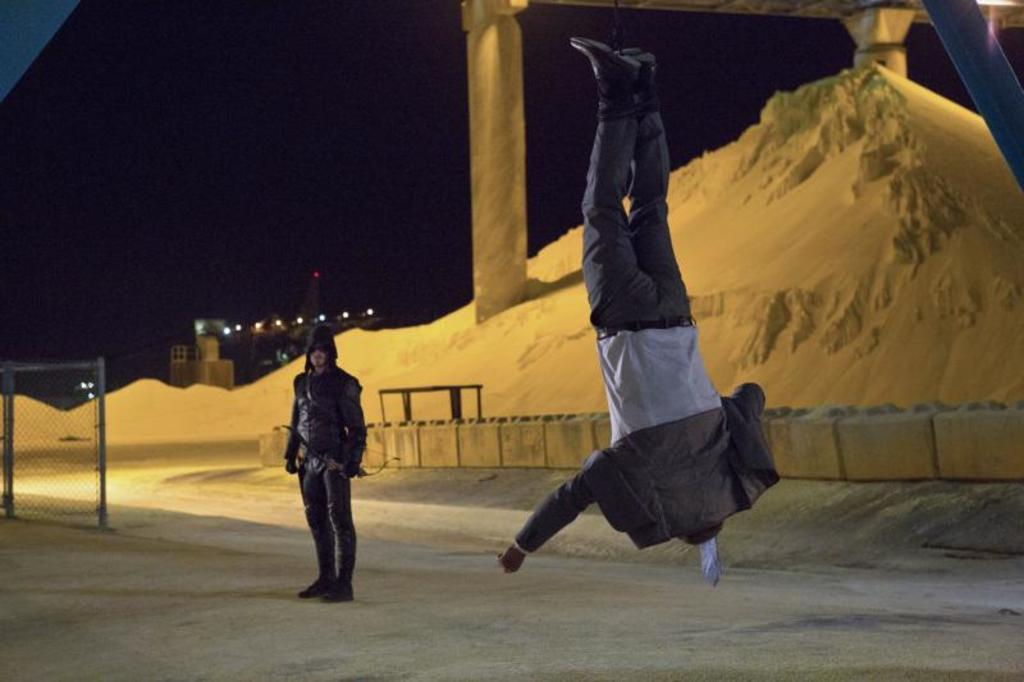How many people are in the image? There are two persons in the image. What is the position of one of the persons? One person is in the air. What type of terrain can be seen in the background? There is sand visible in the background. What architectural features are present in the background? There are pillars in the background. What type of lighting is present in the background? There are lights in the background. What is the color of the sky in the image? The sky appears to be black in color. How many cacti are visible in the image? There are no cacti present in the image. What type of ring is being worn by the person in the air? There is no person wearing a ring in the image. 